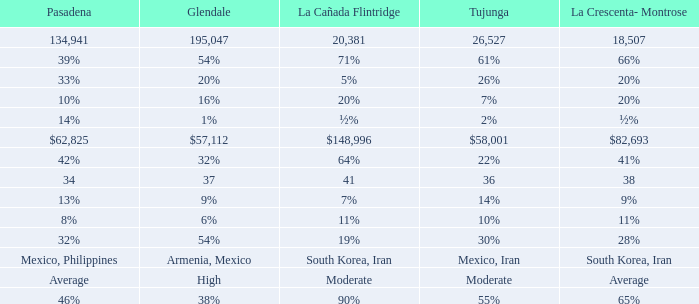When Tujunga is moderate, what is La Crescenta-Montrose? Average. 